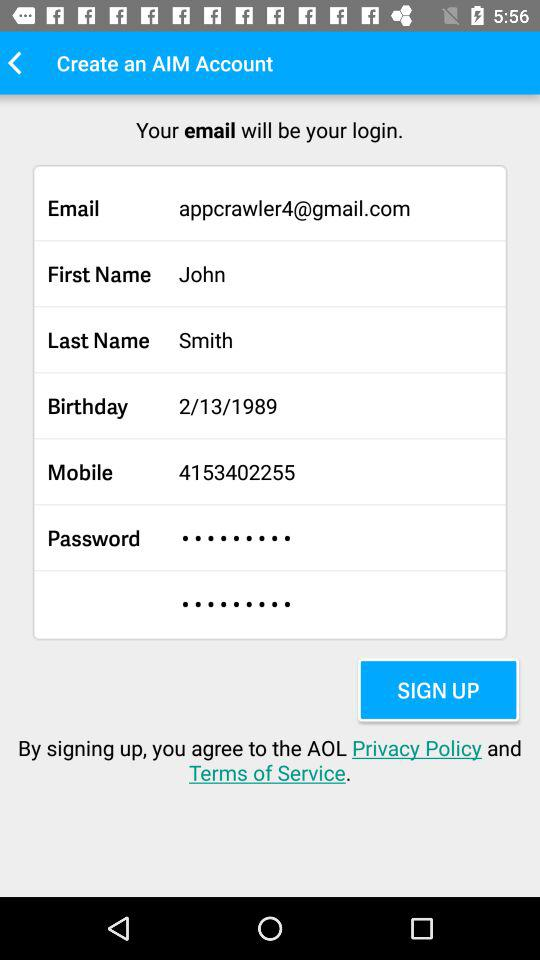What is the email ID? The email ID is appcrawler4@gmail.com. 